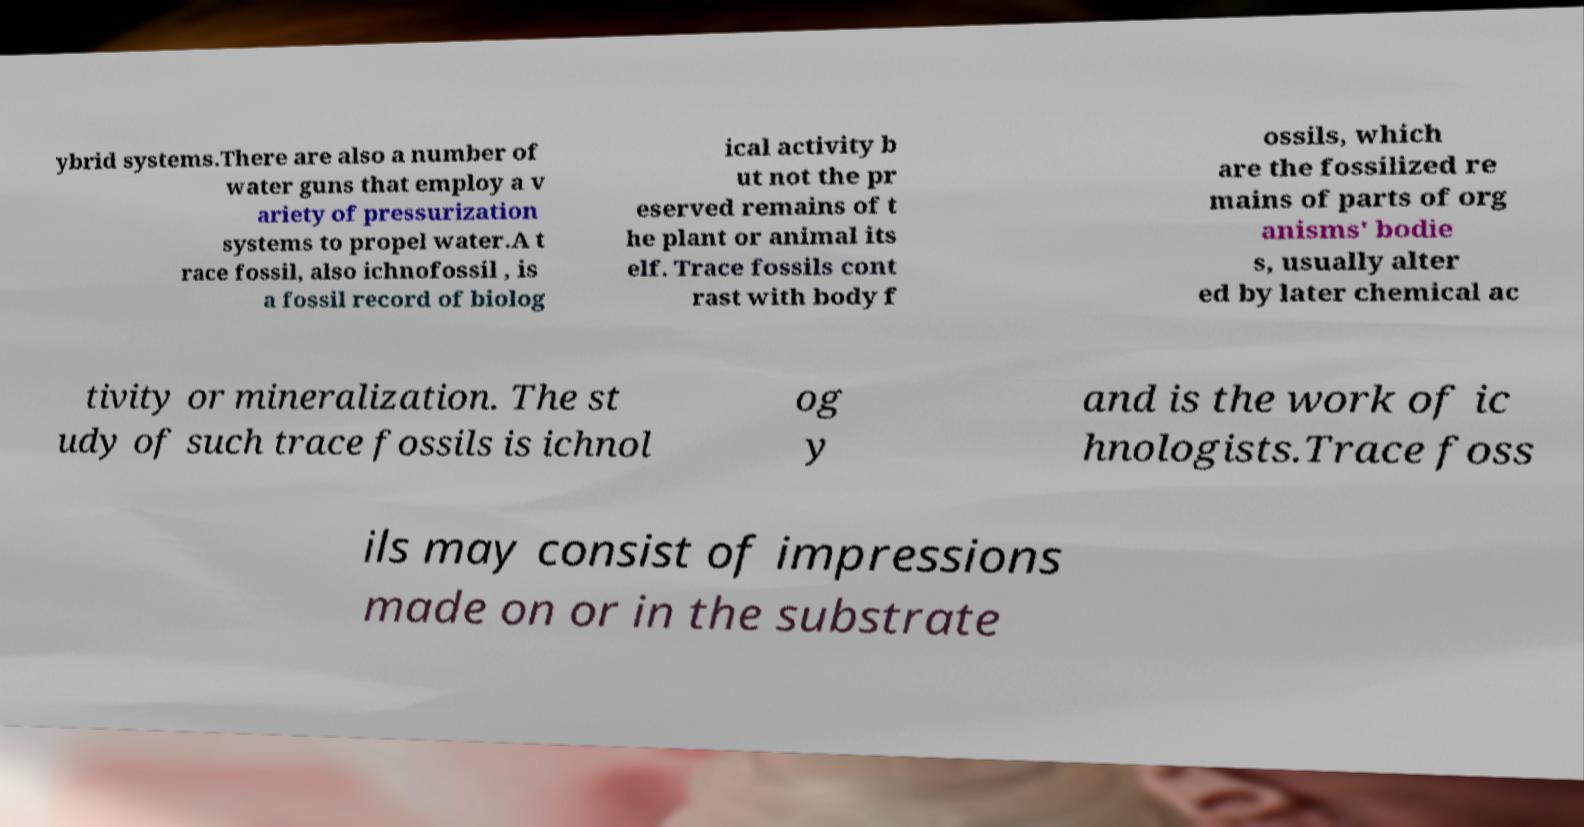There's text embedded in this image that I need extracted. Can you transcribe it verbatim? ybrid systems.There are also a number of water guns that employ a v ariety of pressurization systems to propel water.A t race fossil, also ichnofossil , is a fossil record of biolog ical activity b ut not the pr eserved remains of t he plant or animal its elf. Trace fossils cont rast with body f ossils, which are the fossilized re mains of parts of org anisms' bodie s, usually alter ed by later chemical ac tivity or mineralization. The st udy of such trace fossils is ichnol og y and is the work of ic hnologists.Trace foss ils may consist of impressions made on or in the substrate 